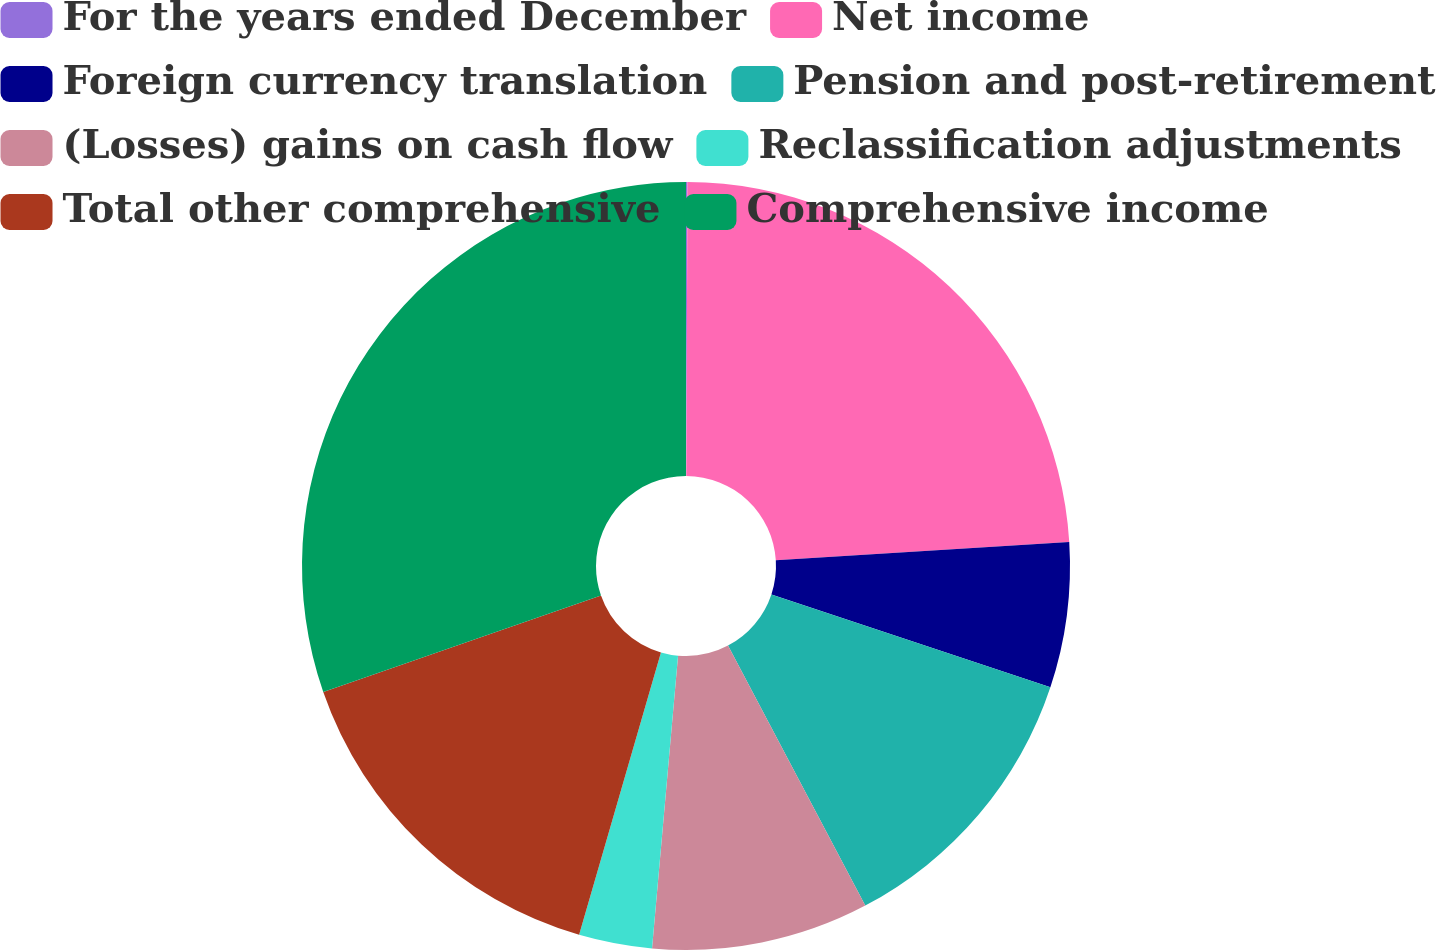Convert chart to OTSL. <chart><loc_0><loc_0><loc_500><loc_500><pie_chart><fcel>For the years ended December<fcel>Net income<fcel>Foreign currency translation<fcel>Pension and post-retirement<fcel>(Losses) gains on cash flow<fcel>Reclassification adjustments<fcel>Total other comprehensive<fcel>Comprehensive income<nl><fcel>0.06%<fcel>23.94%<fcel>6.11%<fcel>12.16%<fcel>9.14%<fcel>3.08%<fcel>15.19%<fcel>30.32%<nl></chart> 